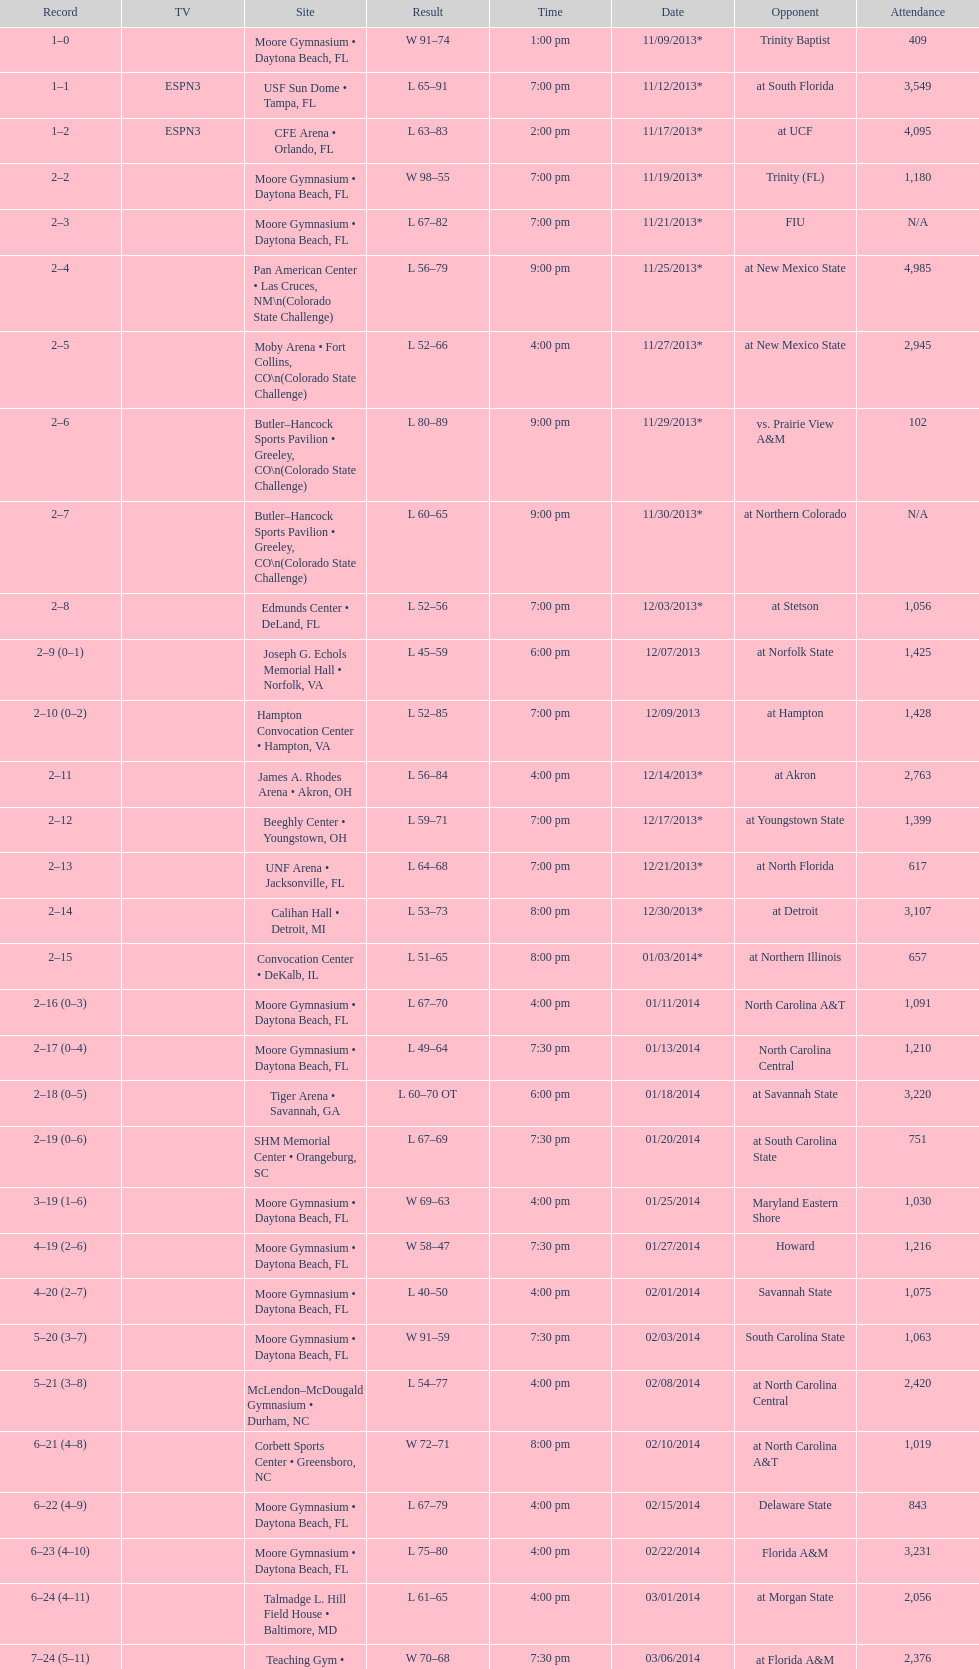Was the attendance of the game held on 11/19/2013 greater than 1,000? Yes. 